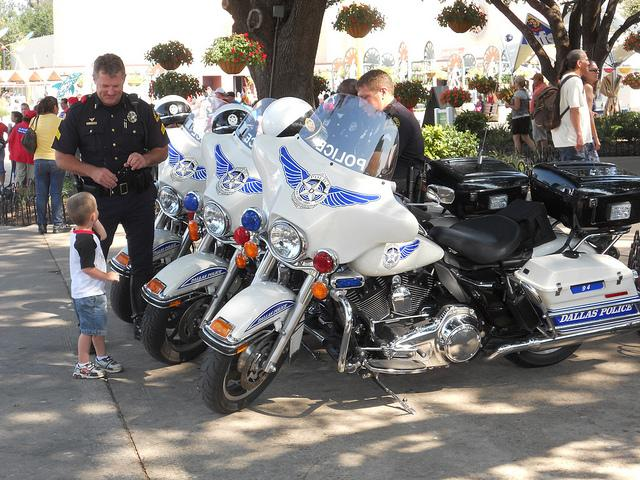What NFL team plays in the town? Please explain your reasoning. cowboys. They are from dallas. 